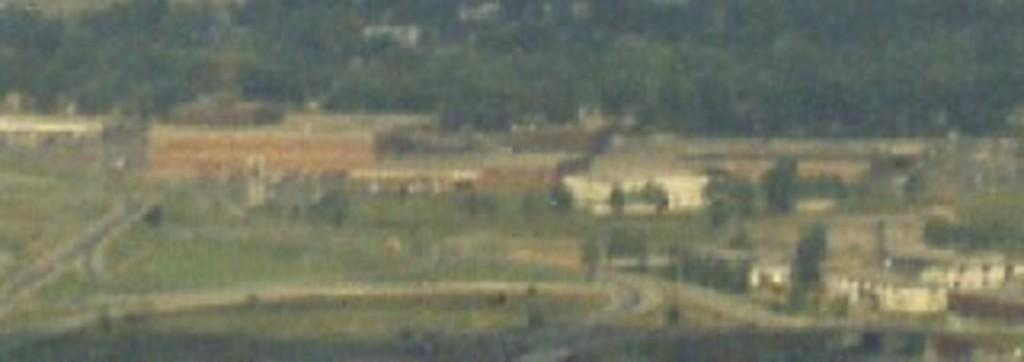What type of view is shown in the image? The image is an aerial view of a town. What can be seen on the right side of the image? There are buildings on the right side of the image. What is visible in the background of the image? Trees are visible in the background of the image. What type of cloth is draped over the train in the image? There is no train or cloth present in the image. How many bells can be heard ringing in the image? There are no bells or sounds present in the image, as it is a still photograph. 